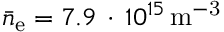<formula> <loc_0><loc_0><loc_500><loc_500>\bar { n } _ { e } = 7 . 9 \, \cdot \, 1 0 ^ { 1 5 } \, { m } ^ { - 3 }</formula> 